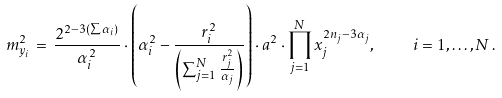<formula> <loc_0><loc_0><loc_500><loc_500>m _ { y _ { i } } ^ { 2 } \, = \, \frac { 2 ^ { 2 - 3 ( \sum \alpha _ { i } ) } } { \alpha _ { i } ^ { 2 } } \cdot \left ( \alpha _ { i } ^ { 2 } - \frac { r _ { i } ^ { 2 } } { \left ( \sum _ { j = 1 } ^ { N } \frac { r _ { j } ^ { 2 } } { \alpha _ { j } } \right ) } \right ) \cdot a ^ { 2 } \cdot \prod _ { j = 1 } ^ { N } x _ { j } ^ { 2 n _ { j } - 3 \alpha _ { j } } , \quad i = 1 , \dots , N \, .</formula> 